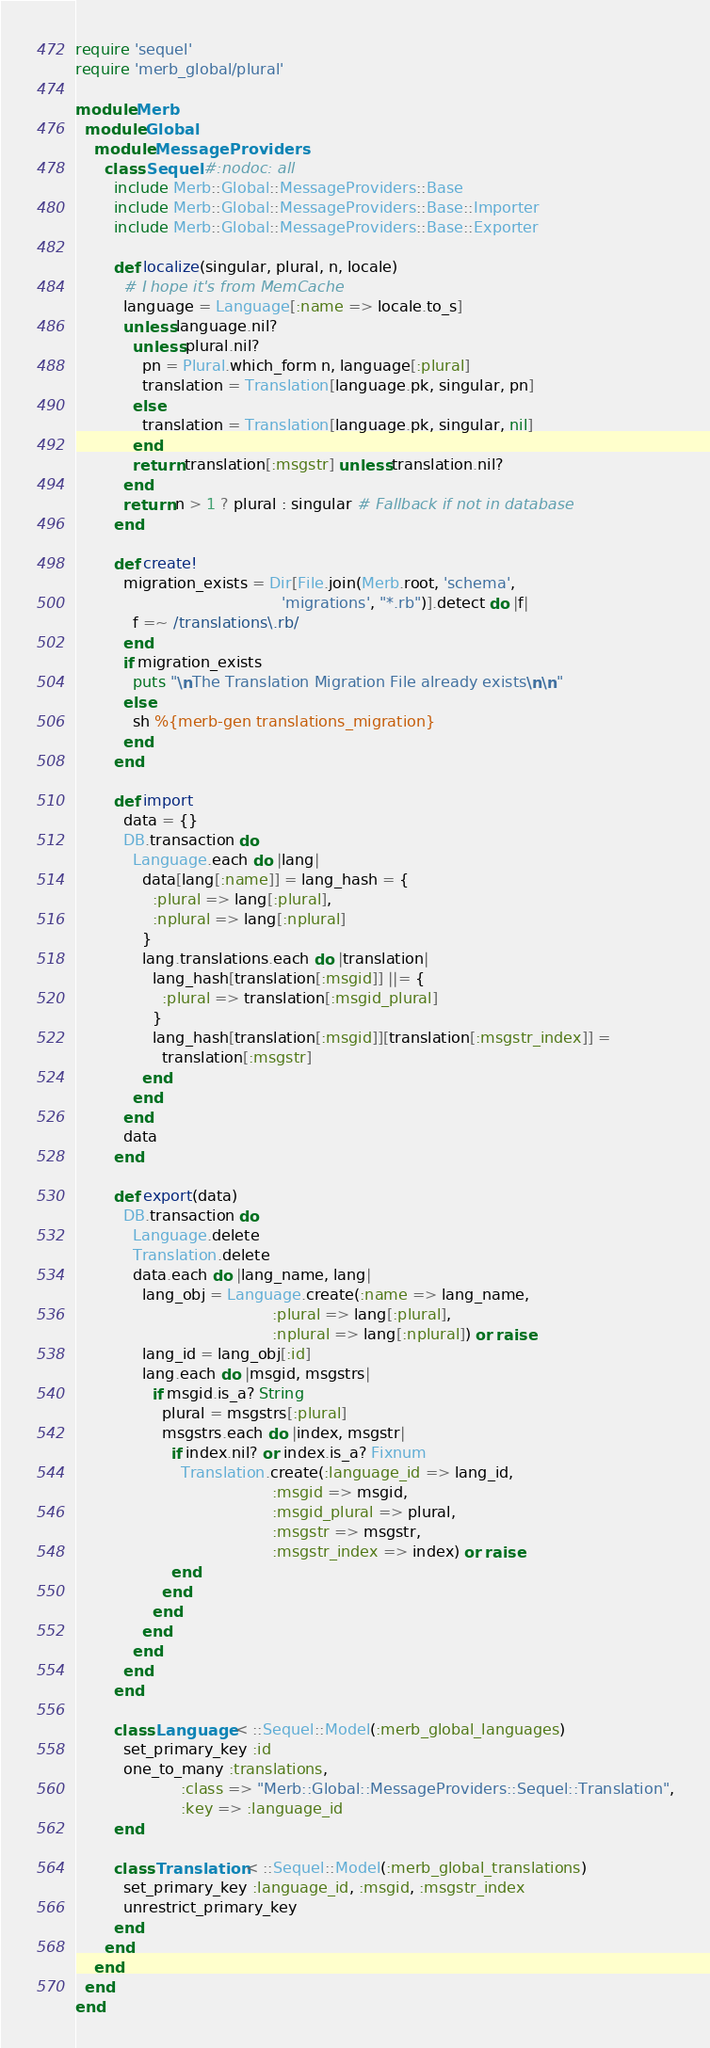Convert code to text. <code><loc_0><loc_0><loc_500><loc_500><_Ruby_>require 'sequel'
require 'merb_global/plural'

module Merb
  module Global
    module MessageProviders
      class Sequel #:nodoc: all
        include Merb::Global::MessageProviders::Base
        include Merb::Global::MessageProviders::Base::Importer
        include Merb::Global::MessageProviders::Base::Exporter

        def localize(singular, plural, n, locale)
          # I hope it's from MemCache
          language = Language[:name => locale.to_s]
          unless language.nil?
            unless plural.nil?
              pn = Plural.which_form n, language[:plural]
              translation = Translation[language.pk, singular, pn]
            else
              translation = Translation[language.pk, singular, nil]
            end
            return translation[:msgstr] unless translation.nil?
          end
          return n > 1 ? plural : singular # Fallback if not in database
        end

        def create!
          migration_exists = Dir[File.join(Merb.root, 'schema',
                                           'migrations', "*.rb")].detect do |f|
            f =~ /translations\.rb/
          end
          if migration_exists
            puts "\nThe Translation Migration File already exists\n\n"
          else
            sh %{merb-gen translations_migration}
          end
        end

        def import
          data = {}
          DB.transaction do
            Language.each do |lang|
              data[lang[:name]] = lang_hash = {
                :plural => lang[:plural],
                :nplural => lang[:nplural]
              }
              lang.translations.each do |translation|
                lang_hash[translation[:msgid]] ||= {
                  :plural => translation[:msgid_plural]
                }
                lang_hash[translation[:msgid]][translation[:msgstr_index]] =
                  translation[:msgstr]
              end
            end
          end
          data
        end

        def export(data)
          DB.transaction do
            Language.delete
            Translation.delete
            data.each do |lang_name, lang|
              lang_obj = Language.create(:name => lang_name,
                                         :plural => lang[:plural],
                                         :nplural => lang[:nplural]) or raise
              lang_id = lang_obj[:id]
              lang.each do |msgid, msgstrs|
                if msgid.is_a? String
                  plural = msgstrs[:plural]
                  msgstrs.each do |index, msgstr|
                    if index.nil? or index.is_a? Fixnum
                      Translation.create(:language_id => lang_id,
                                         :msgid => msgid,
                                         :msgid_plural => plural,
                                         :msgstr => msgstr,
                                         :msgstr_index => index) or raise
                    end
                  end
                end
              end
            end
          end
        end

        class Language < ::Sequel::Model(:merb_global_languages)
          set_primary_key :id
          one_to_many :translations,
                      :class => "Merb::Global::MessageProviders::Sequel::Translation",
                      :key => :language_id
        end

        class Translation < ::Sequel::Model(:merb_global_translations)
          set_primary_key :language_id, :msgid, :msgstr_index
          unrestrict_primary_key
        end
      end
    end
  end
end
</code> 